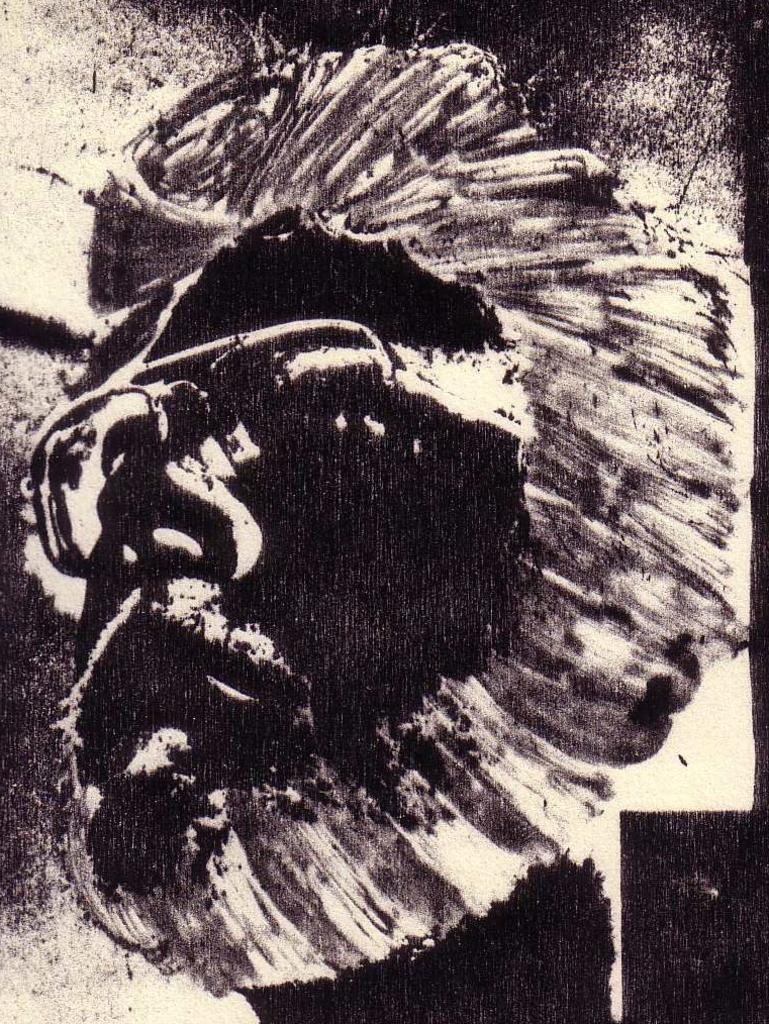What is depicted in the image? There is a drawing of a person's face in the image. How many sheep can be seen grazing on the railway in the image? There are no sheep or railway present in the image; it features a drawing of a person's face. 